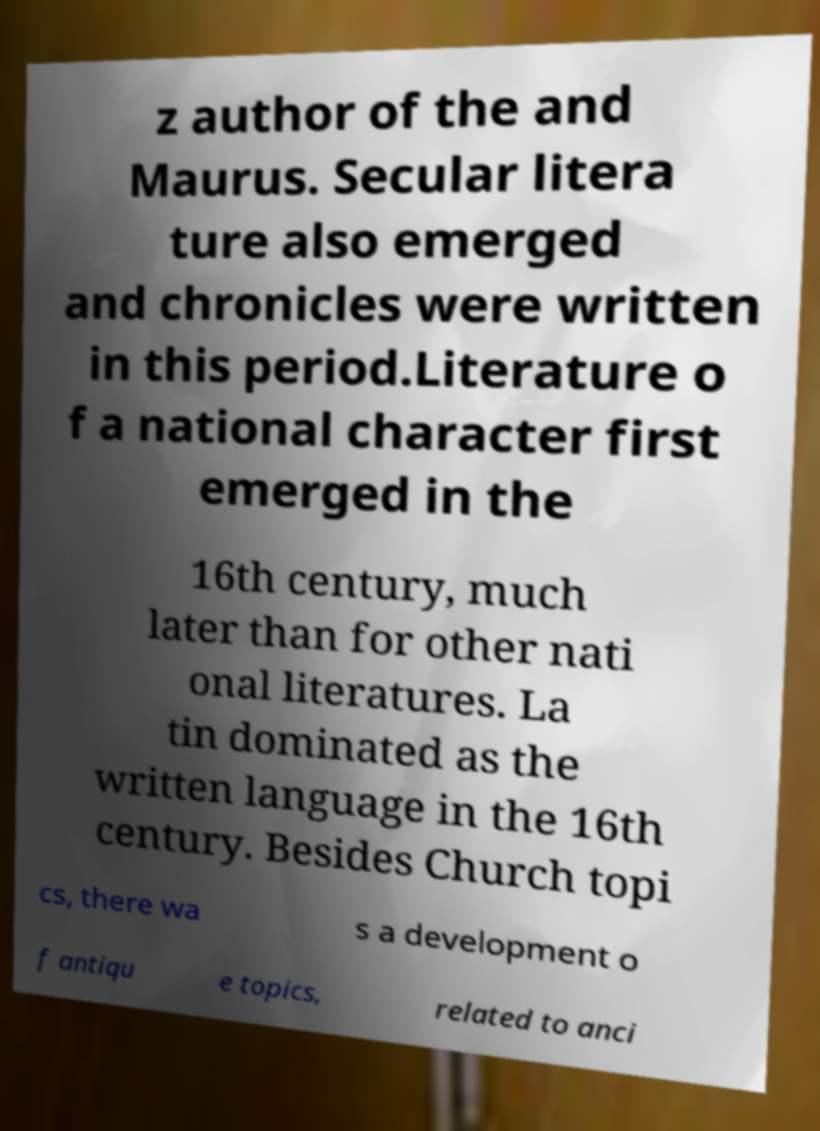Please identify and transcribe the text found in this image. z author of the and Maurus. Secular litera ture also emerged and chronicles were written in this period.Literature o f a national character first emerged in the 16th century, much later than for other nati onal literatures. La tin dominated as the written language in the 16th century. Besides Church topi cs, there wa s a development o f antiqu e topics, related to anci 